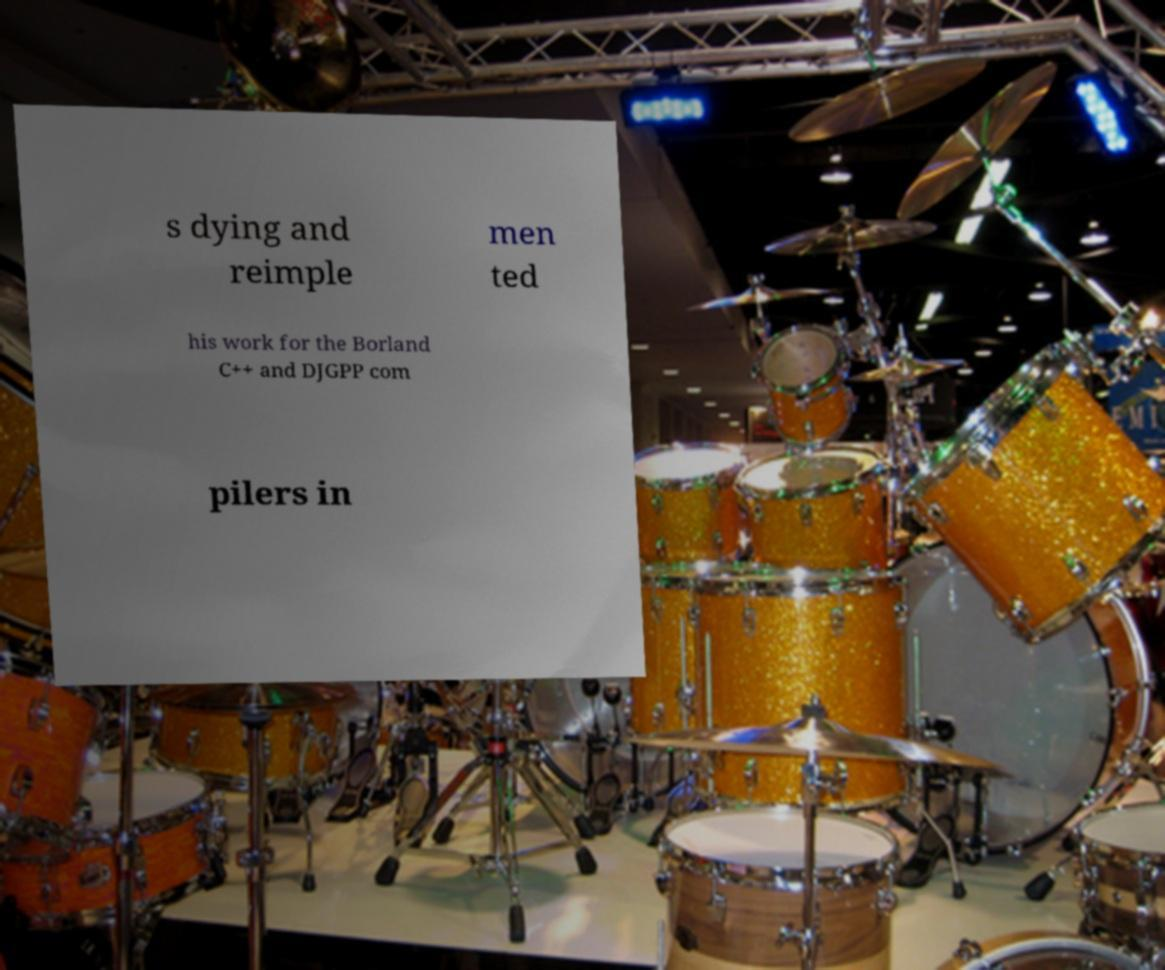I need the written content from this picture converted into text. Can you do that? s dying and reimple men ted his work for the Borland C++ and DJGPP com pilers in 